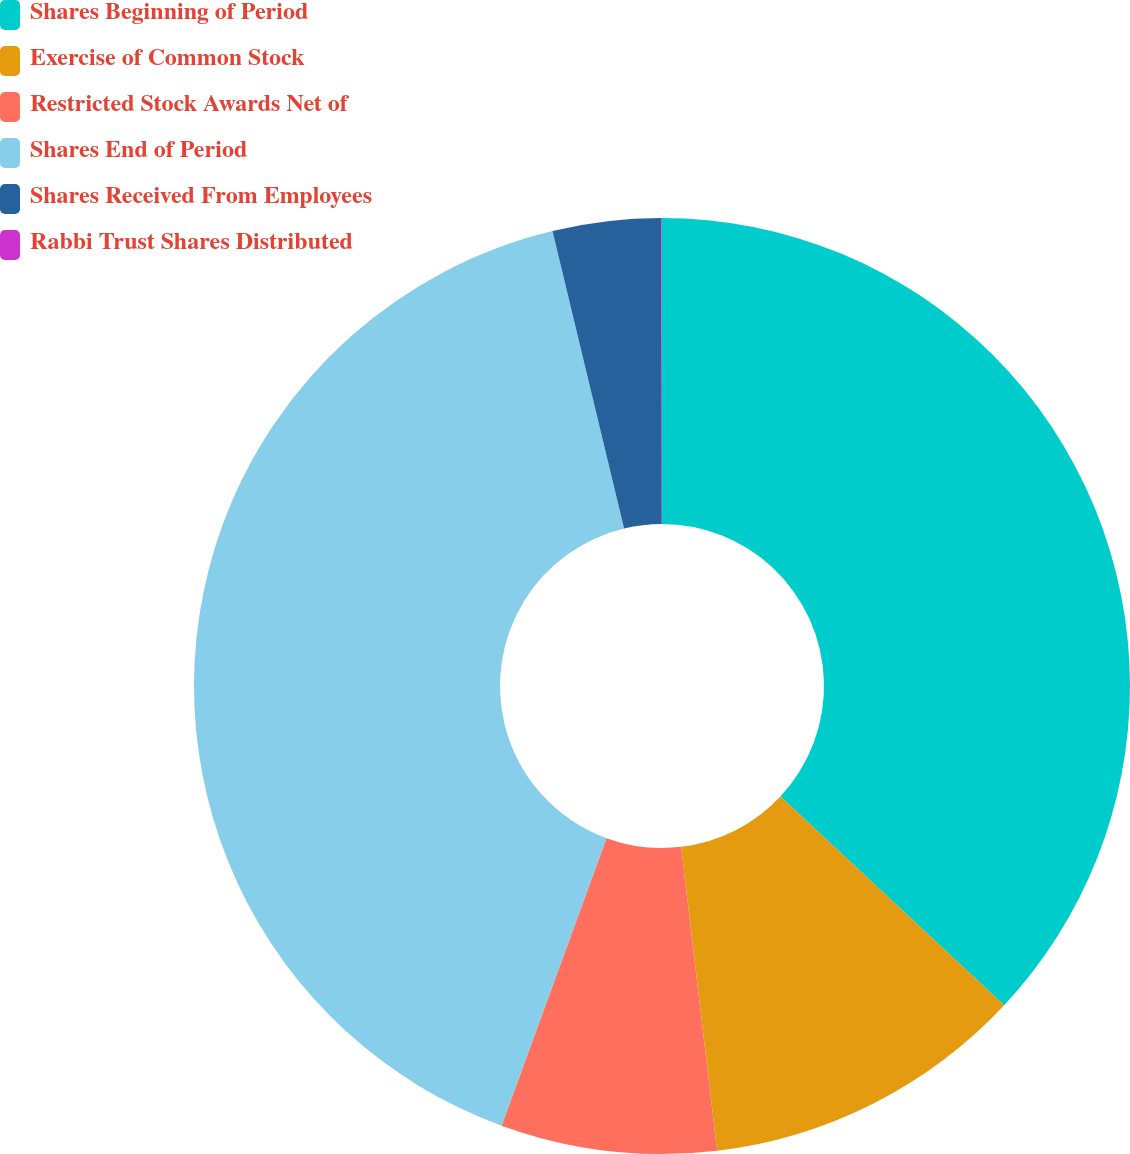Convert chart to OTSL. <chart><loc_0><loc_0><loc_500><loc_500><pie_chart><fcel>Shares Beginning of Period<fcel>Exercise of Common Stock<fcel>Restricted Stock Awards Net of<fcel>Shares End of Period<fcel>Shares Received From Employees<fcel>Rabbi Trust Shares Distributed<nl><fcel>36.95%<fcel>11.17%<fcel>7.45%<fcel>40.67%<fcel>3.74%<fcel>0.02%<nl></chart> 